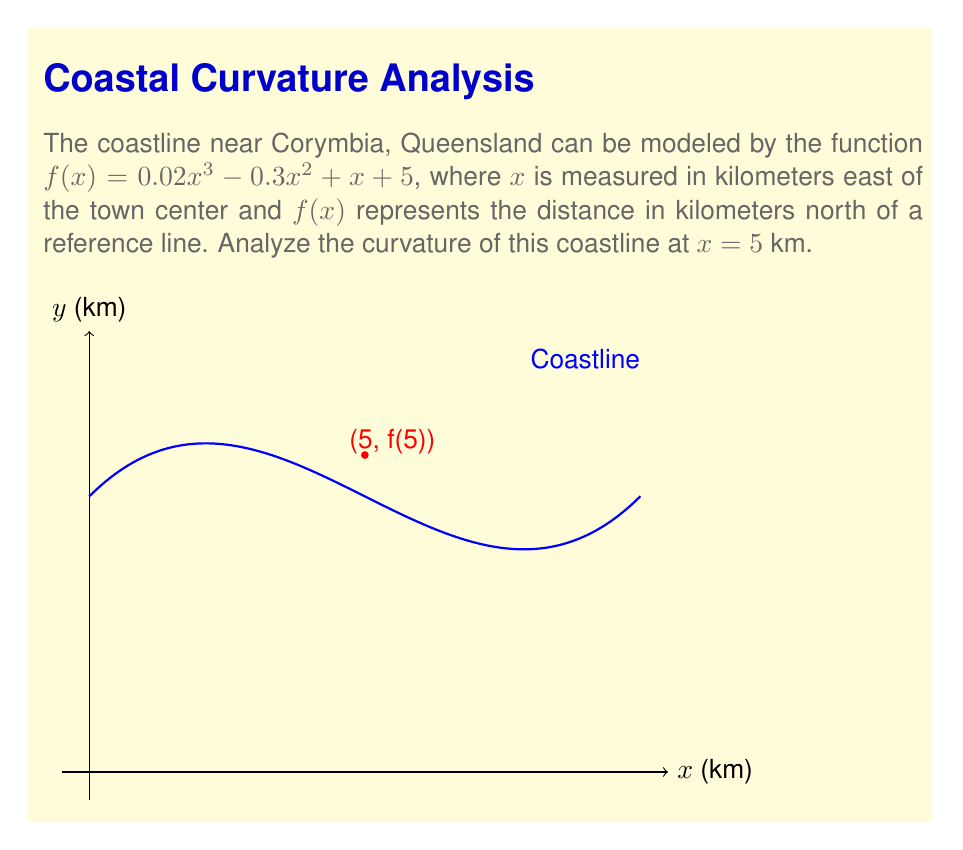Teach me how to tackle this problem. To analyze the curvature, we need to calculate the second derivative of $f(x)$ and evaluate it at $x = 5$ km.

Step 1: Find the first derivative.
$$f'(x) = 0.06x^2 - 0.6x + 1$$

Step 2: Find the second derivative.
$$f''(x) = 0.12x - 0.6$$

Step 3: Evaluate $f''(x)$ at $x = 5$.
$$f''(5) = 0.12(5) - 0.6 = 0.6 - 0.6 = 0$$

Step 4: Interpret the result.
The second derivative at $x = 5$ is zero, which means this point is an inflection point of the coastline. The curvature changes from concave to convex (or vice versa) at this point.

Step 5: Determine concavity before and after $x = 5$.
For $x < 5$: $f''(x) < 0$, so the coastline is concave down.
For $x > 5$: $f''(x) > 0$, so the coastline is concave up.
Answer: Inflection point at $x = 5$ km; concave down for $x < 5$, concave up for $x > 5$. 